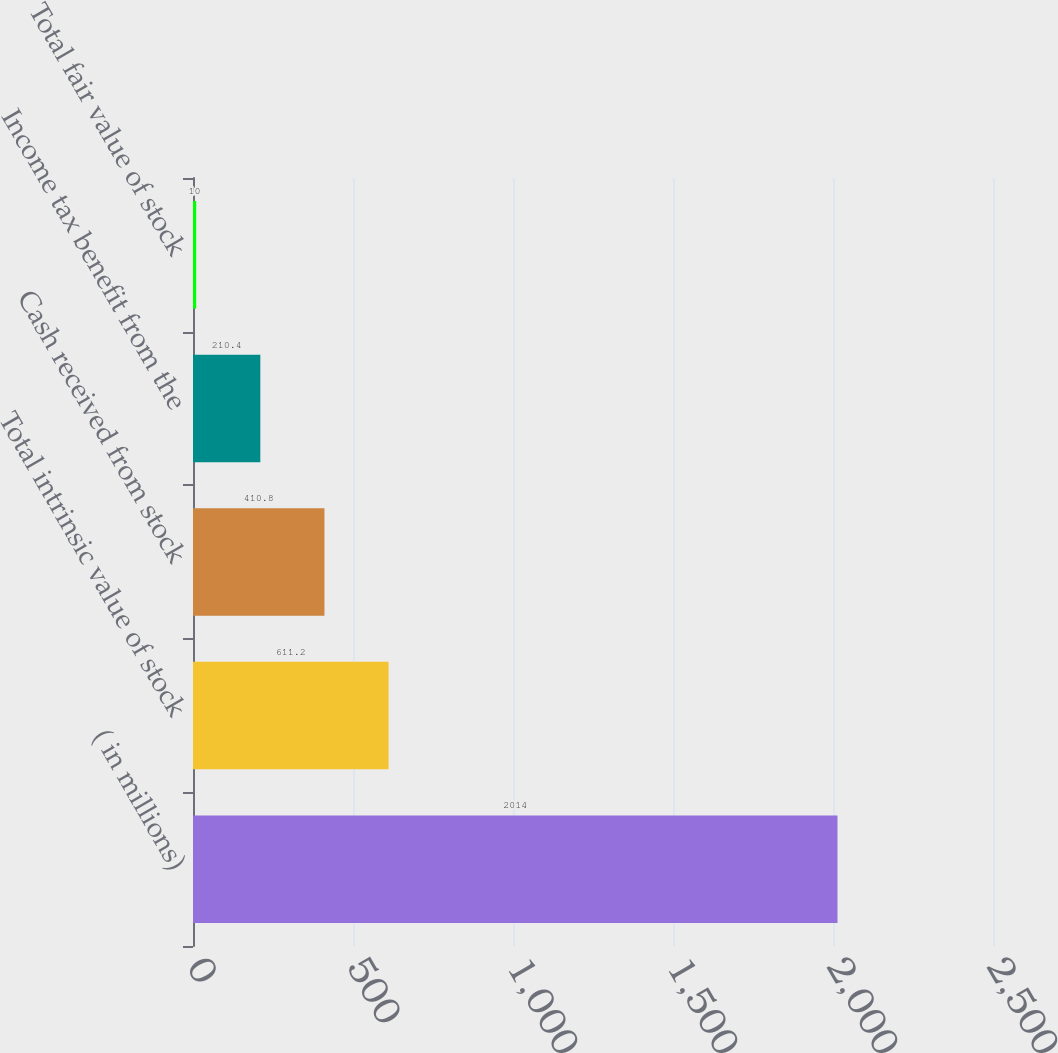Convert chart. <chart><loc_0><loc_0><loc_500><loc_500><bar_chart><fcel>( in millions)<fcel>Total intrinsic value of stock<fcel>Cash received from stock<fcel>Income tax benefit from the<fcel>Total fair value of stock<nl><fcel>2014<fcel>611.2<fcel>410.8<fcel>210.4<fcel>10<nl></chart> 